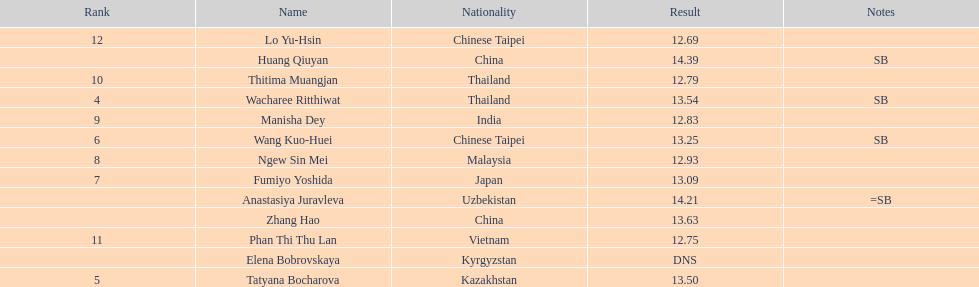How many athletes had a better result than tatyana bocharova? 4. 